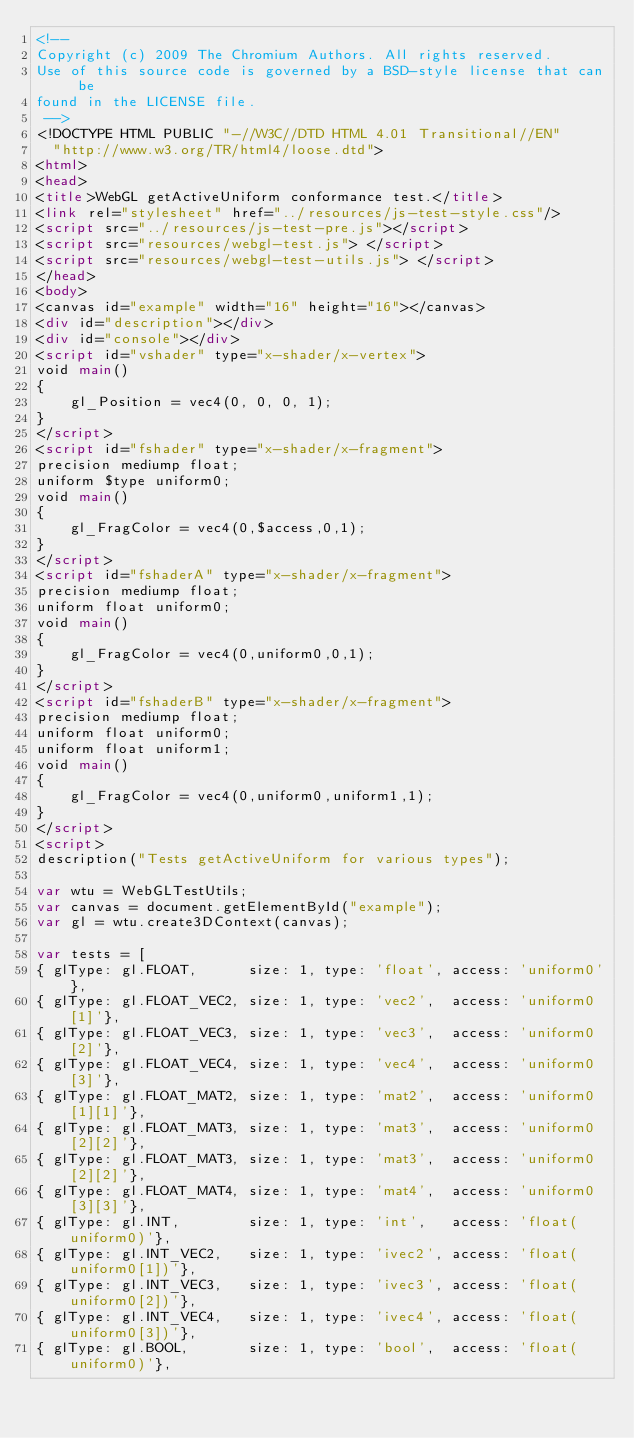<code> <loc_0><loc_0><loc_500><loc_500><_HTML_><!--
Copyright (c) 2009 The Chromium Authors. All rights reserved.
Use of this source code is governed by a BSD-style license that can be
found in the LICENSE file.
 -->
<!DOCTYPE HTML PUBLIC "-//W3C//DTD HTML 4.01 Transitional//EN"
  "http://www.w3.org/TR/html4/loose.dtd">
<html>
<head>
<title>WebGL getActiveUniform conformance test.</title>
<link rel="stylesheet" href="../resources/js-test-style.css"/>
<script src="../resources/js-test-pre.js"></script>
<script src="resources/webgl-test.js"> </script>
<script src="resources/webgl-test-utils.js"> </script>
</head>
<body>
<canvas id="example" width="16" height="16"></canvas>
<div id="description"></div>
<div id="console"></div>
<script id="vshader" type="x-shader/x-vertex">
void main()
{
    gl_Position = vec4(0, 0, 0, 1);
}
</script>
<script id="fshader" type="x-shader/x-fragment">
precision mediump float;
uniform $type uniform0;
void main()
{
    gl_FragColor = vec4(0,$access,0,1);
}
</script>
<script id="fshaderA" type="x-shader/x-fragment">
precision mediump float;
uniform float uniform0;
void main()
{
    gl_FragColor = vec4(0,uniform0,0,1);
}
</script>
<script id="fshaderB" type="x-shader/x-fragment">
precision mediump float;
uniform float uniform0;
uniform float uniform1;
void main()
{
    gl_FragColor = vec4(0,uniform0,uniform1,1);
}
</script>
<script>
description("Tests getActiveUniform for various types");

var wtu = WebGLTestUtils;
var canvas = document.getElementById("example");
var gl = wtu.create3DContext(canvas);

var tests = [
{ glType: gl.FLOAT,      size: 1, type: 'float', access: 'uniform0'},
{ glType: gl.FLOAT_VEC2, size: 1, type: 'vec2',  access: 'uniform0[1]'},
{ glType: gl.FLOAT_VEC3, size: 1, type: 'vec3',  access: 'uniform0[2]'},
{ glType: gl.FLOAT_VEC4, size: 1, type: 'vec4',  access: 'uniform0[3]'},
{ glType: gl.FLOAT_MAT2, size: 1, type: 'mat2',  access: 'uniform0[1][1]'},
{ glType: gl.FLOAT_MAT3, size: 1, type: 'mat3',  access: 'uniform0[2][2]'},
{ glType: gl.FLOAT_MAT3, size: 1, type: 'mat3',  access: 'uniform0[2][2]'},
{ glType: gl.FLOAT_MAT4, size: 1, type: 'mat4',  access: 'uniform0[3][3]'},
{ glType: gl.INT,        size: 1, type: 'int',   access: 'float(uniform0)'},
{ glType: gl.INT_VEC2,   size: 1, type: 'ivec2', access: 'float(uniform0[1])'},
{ glType: gl.INT_VEC3,   size: 1, type: 'ivec3', access: 'float(uniform0[2])'},
{ glType: gl.INT_VEC4,   size: 1, type: 'ivec4', access: 'float(uniform0[3])'},
{ glType: gl.BOOL,       size: 1, type: 'bool',  access: 'float(uniform0)'},</code> 